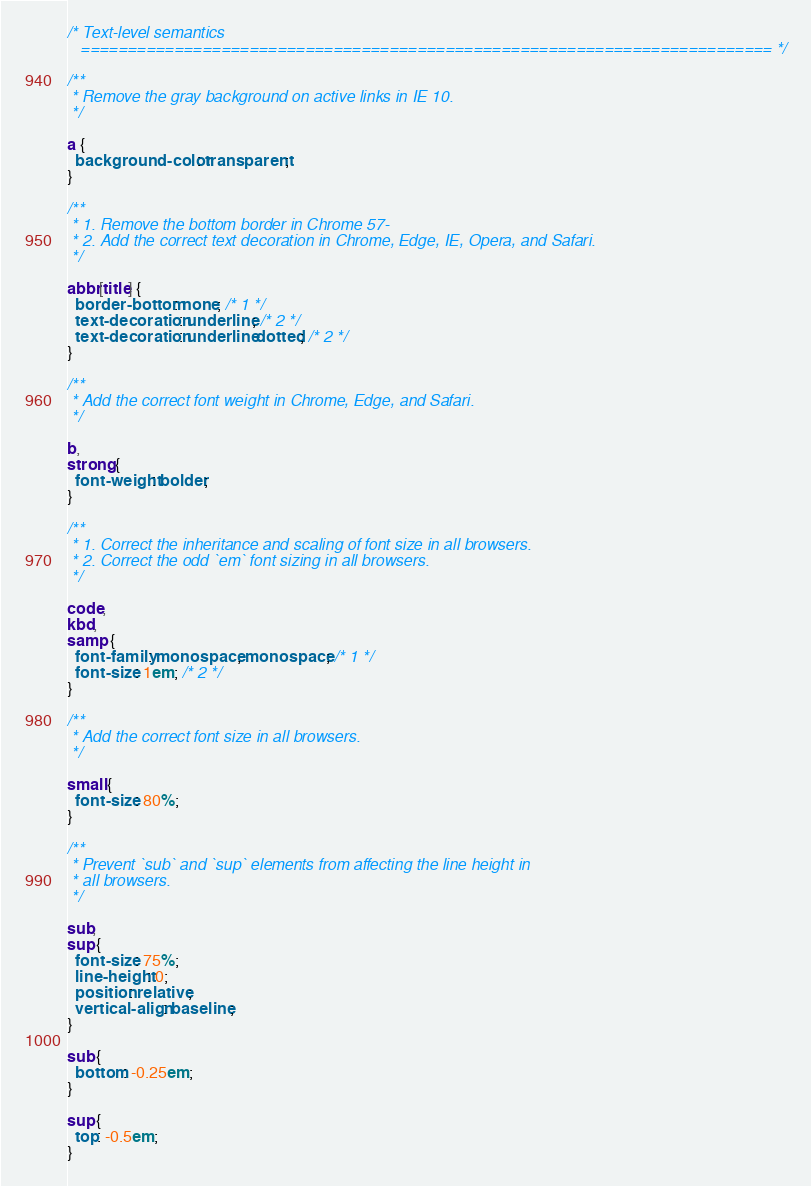Convert code to text. <code><loc_0><loc_0><loc_500><loc_500><_CSS_>/* Text-level semantics
   ========================================================================== */

/**
 * Remove the gray background on active links in IE 10.
 */

a {
  background-color: transparent;
}

/**
 * 1. Remove the bottom border in Chrome 57-
 * 2. Add the correct text decoration in Chrome, Edge, IE, Opera, and Safari.
 */

abbr[title] {
  border-bottom: none; /* 1 */
  text-decoration: underline; /* 2 */
  text-decoration: underline dotted; /* 2 */
}

/**
 * Add the correct font weight in Chrome, Edge, and Safari.
 */

b,
strong {
  font-weight: bolder;
}

/**
 * 1. Correct the inheritance and scaling of font size in all browsers.
 * 2. Correct the odd `em` font sizing in all browsers.
 */

code,
kbd,
samp {
  font-family: monospace, monospace; /* 1 */
  font-size: 1em; /* 2 */
}

/**
 * Add the correct font size in all browsers.
 */

small {
  font-size: 80%;
}

/**
 * Prevent `sub` and `sup` elements from affecting the line height in
 * all browsers.
 */

sub,
sup {
  font-size: 75%;
  line-height: 0;
  position: relative;
  vertical-align: baseline;
}

sub {
  bottom: -0.25em;
}

sup {
  top: -0.5em;
}
</code> 